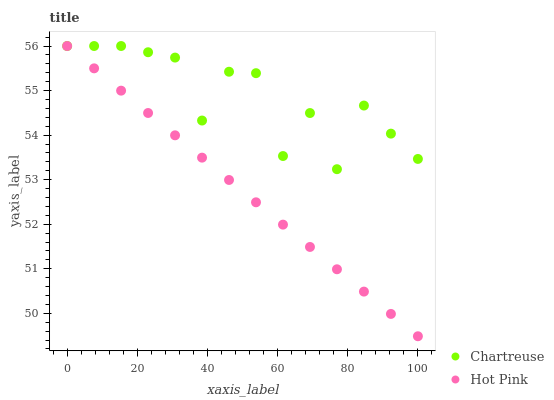Does Hot Pink have the minimum area under the curve?
Answer yes or no. Yes. Does Chartreuse have the maximum area under the curve?
Answer yes or no. Yes. Does Hot Pink have the maximum area under the curve?
Answer yes or no. No. Is Hot Pink the smoothest?
Answer yes or no. Yes. Is Chartreuse the roughest?
Answer yes or no. Yes. Is Hot Pink the roughest?
Answer yes or no. No. Does Hot Pink have the lowest value?
Answer yes or no. Yes. Does Hot Pink have the highest value?
Answer yes or no. Yes. Does Chartreuse intersect Hot Pink?
Answer yes or no. Yes. Is Chartreuse less than Hot Pink?
Answer yes or no. No. Is Chartreuse greater than Hot Pink?
Answer yes or no. No. 